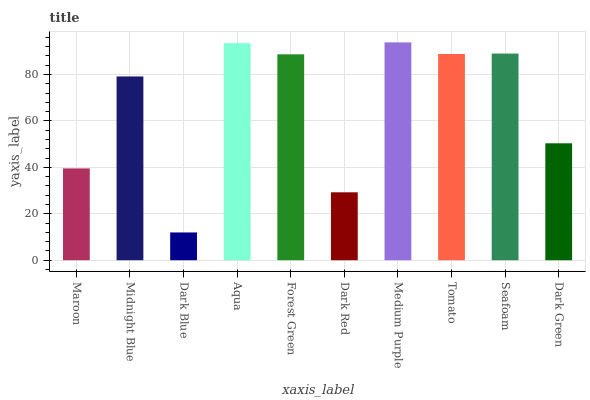Is Dark Blue the minimum?
Answer yes or no. Yes. Is Medium Purple the maximum?
Answer yes or no. Yes. Is Midnight Blue the minimum?
Answer yes or no. No. Is Midnight Blue the maximum?
Answer yes or no. No. Is Midnight Blue greater than Maroon?
Answer yes or no. Yes. Is Maroon less than Midnight Blue?
Answer yes or no. Yes. Is Maroon greater than Midnight Blue?
Answer yes or no. No. Is Midnight Blue less than Maroon?
Answer yes or no. No. Is Forest Green the high median?
Answer yes or no. Yes. Is Midnight Blue the low median?
Answer yes or no. Yes. Is Dark Red the high median?
Answer yes or no. No. Is Forest Green the low median?
Answer yes or no. No. 